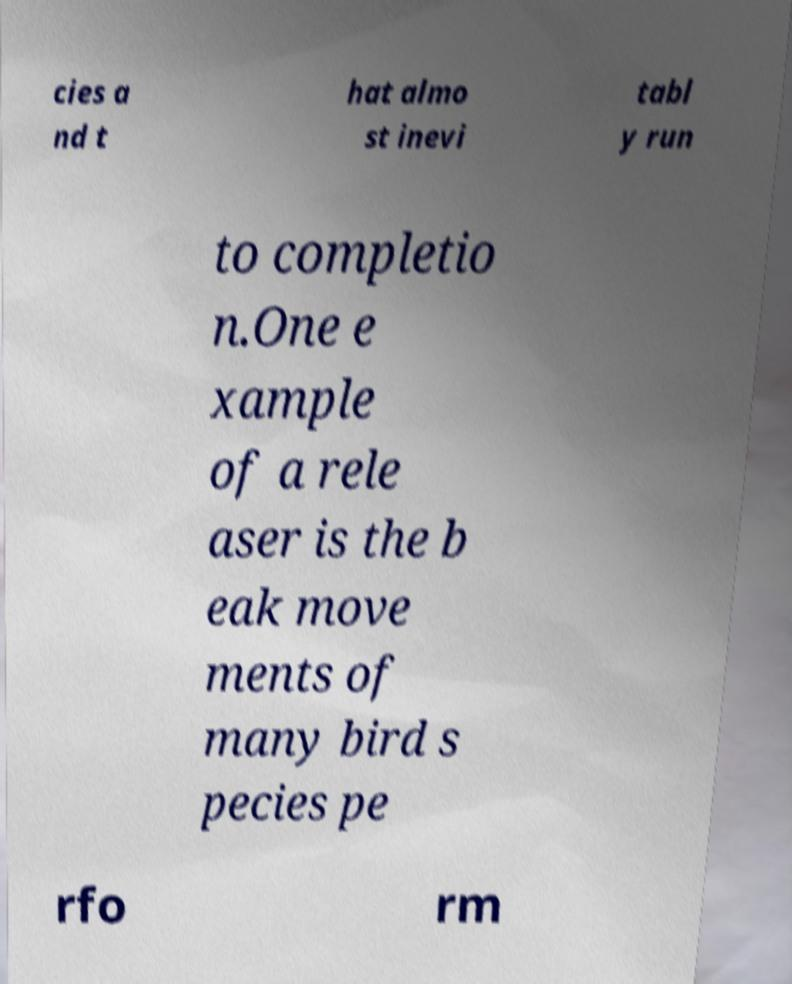There's text embedded in this image that I need extracted. Can you transcribe it verbatim? cies a nd t hat almo st inevi tabl y run to completio n.One e xample of a rele aser is the b eak move ments of many bird s pecies pe rfo rm 